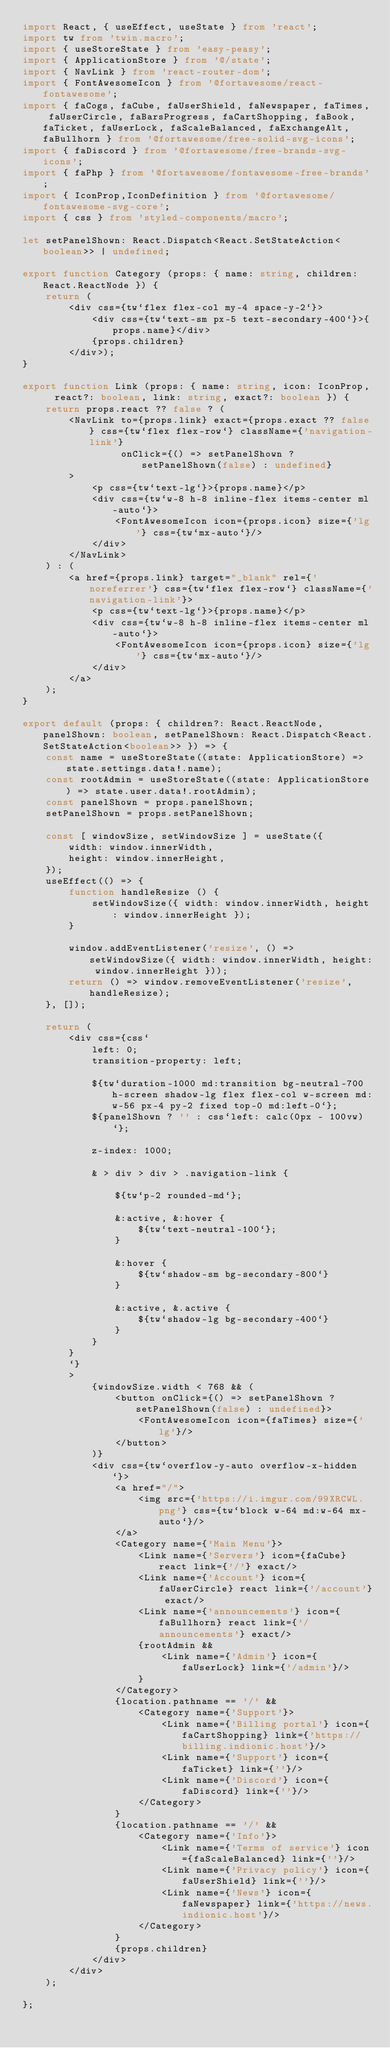<code> <loc_0><loc_0><loc_500><loc_500><_TypeScript_>import React, { useEffect, useState } from 'react';
import tw from 'twin.macro';
import { useStoreState } from 'easy-peasy';
import { ApplicationStore } from '@/state';
import { NavLink } from 'react-router-dom';
import { FontAwesomeIcon } from '@fortawesome/react-fontawesome';
import { faCogs, faCube, faUserShield, faNewspaper, faTimes, faUserCircle, faBarsProgress, faCartShopping, faBook, faTicket, faUserLock, faScaleBalanced, faExchangeAlt, faBullhorn } from '@fortawesome/free-solid-svg-icons';
import { faDiscord } from '@fortawesome/free-brands-svg-icons';
import { faPhp } from '@fortawesome/fontawesome-free-brands';
import { IconProp,IconDefinition } from '@fortawesome/fontawesome-svg-core';
import { css } from 'styled-components/macro';

let setPanelShown: React.Dispatch<React.SetStateAction<boolean>> | undefined;

export function Category (props: { name: string, children: React.ReactNode }) {
    return (
        <div css={tw`flex flex-col my-4 space-y-2`}>
            <div css={tw`text-sm px-5 text-secondary-400`}>{props.name}</div>
            {props.children}
        </div>);
}

export function Link (props: { name: string, icon: IconProp,  react?: boolean, link: string, exact?: boolean }) {
    return props.react ?? false ? (
        <NavLink to={props.link} exact={props.exact ?? false} css={tw`flex flex-row`} className={'navigation-link'}
                 onClick={() => setPanelShown ? setPanelShown(false) : undefined}
        >
            <p css={tw`text-lg`}>{props.name}</p>
            <div css={tw`w-8 h-8 inline-flex items-center ml-auto`}>
                <FontAwesomeIcon icon={props.icon} size={'lg'} css={tw`mx-auto`}/>
            </div>
        </NavLink>
    ) : (
        <a href={props.link} target="_blank" rel={'noreferrer'} css={tw`flex flex-row`} className={'navigation-link'}>
            <p css={tw`text-lg`}>{props.name}</p>
            <div css={tw`w-8 h-8 inline-flex items-center ml-auto`}>
                <FontAwesomeIcon icon={props.icon} size={'lg'} css={tw`mx-auto`}/>
            </div>
        </a>
    );
}

export default (props: { children?: React.ReactNode, panelShown: boolean, setPanelShown: React.Dispatch<React.SetStateAction<boolean>> }) => {
    const name = useStoreState((state: ApplicationStore) => state.settings.data!.name);
    const rootAdmin = useStoreState((state: ApplicationStore) => state.user.data!.rootAdmin);
    const panelShown = props.panelShown;
    setPanelShown = props.setPanelShown;

    const [ windowSize, setWindowSize ] = useState({
        width: window.innerWidth,
        height: window.innerHeight,
    });
    useEffect(() => {
        function handleResize () {
            setWindowSize({ width: window.innerWidth, height: window.innerHeight });
        }

        window.addEventListener('resize', () => setWindowSize({ width: window.innerWidth, height: window.innerHeight }));
        return () => window.removeEventListener('resize', handleResize);
    }, []);

    return (
        <div css={css`
            left: 0;
            transition-property: left;

            ${tw`duration-1000 md:transition bg-neutral-700 h-screen shadow-lg flex flex-col w-screen md:w-56 px-4 py-2 fixed top-0 md:left-0`};
            ${panelShown ? '' : css`left: calc(0px - 100vw)`};

            z-index: 1000;

            & > div > div > .navigation-link {

                ${tw`p-2 rounded-md`};

                &:active, &:hover {
                    ${tw`text-neutral-100`};
                }

                &:hover {
                    ${tw`shadow-sm bg-secondary-800`}
                }

                &:active, &.active {
                    ${tw`shadow-lg bg-secondary-400`}
                }
            }
        }
        `}
        >
            {windowSize.width < 768 && (
                <button onClick={() => setPanelShown ? setPanelShown(false) : undefined}>
                    <FontAwesomeIcon icon={faTimes} size={'lg'}/>
                </button>
            )}
            <div css={tw`overflow-y-auto overflow-x-hidden`}>
                <a href="/">
                    <img src={'https://i.imgur.com/99XRCWL.png'} css={tw`block w-64 md:w-64 mx-auto`}/>
                </a>
                <Category name={'Main Menu'}>
                    <Link name={'Servers'} icon={faCube} react link={'/'} exact/>
                    <Link name={'Account'} icon={faUserCircle} react link={'/account'} exact/>
                    <Link name={'announcements'} icon={faBullhorn} react link={'/announcements'} exact/>
                    {rootAdmin &&
                        <Link name={'Admin'} icon={faUserLock} link={'/admin'}/>
                    }
                </Category>
                {location.pathname == '/' &&
                    <Category name={'Support'}>
                        <Link name={'Billing portal'} icon={faCartShopping} link={'https://billing.indionic.host'}/>
                        <Link name={'Support'} icon={faTicket} link={''}/>
                        <Link name={'Discord'} icon={faDiscord} link={''}/>
                    </Category>
                }
                {location.pathname == '/' &&
                    <Category name={'Info'}>
                        <Link name={'Terms of service'} icon={faScaleBalanced} link={''}/>
                        <Link name={'Privacy policy'} icon={faUserShield} link={''}/>
                        <Link name={'News'} icon={faNewspaper} link={'https://news.indionic.host'}/>
                    </Category>
                }
                {props.children}
            </div>
        </div>
    );

};

</code> 